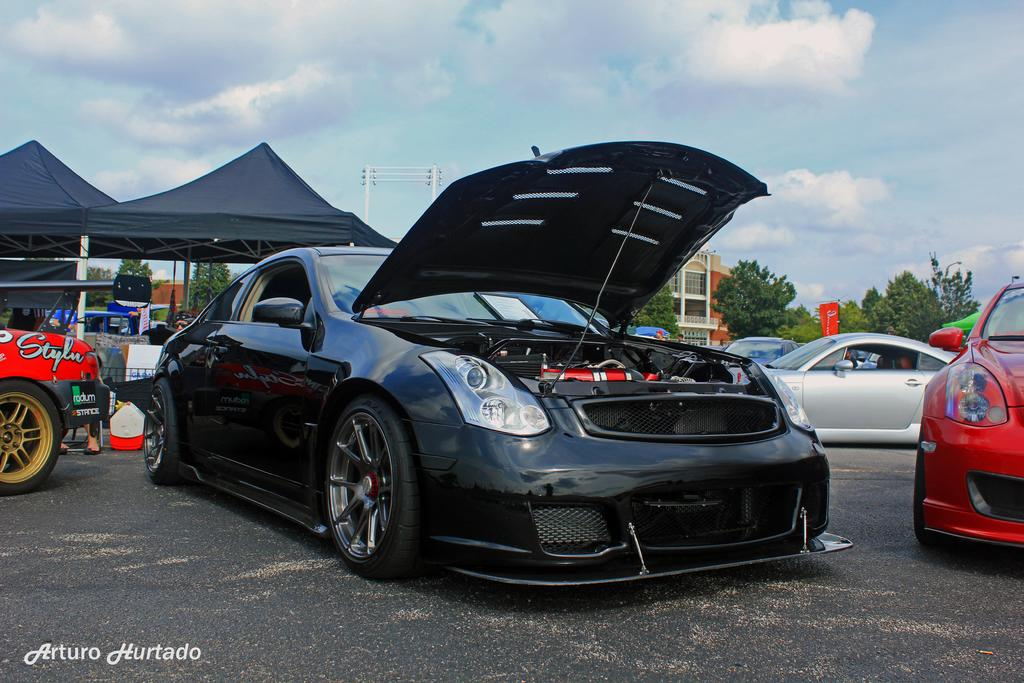What can be seen parked in the image? There are vehicles parked in the image. What structure is present above the parked vehicles? There is a canopy in the image. What type of man-made structures are visible in the image? There are buildings in the image. What type of natural elements are present in the image? There are trees in the image. What tall structures can be seen in the image? There are utility poles in the image. What is visible at the top of the image? The sky is visible in the image. What type of basin is visible in the image? There is no basin present in the image. How does the edge of the canopy affect the taste of the vehicles parked underneath? The edge of the canopy does not affect the taste of the vehicles parked underneath, as it is not related to the taste of the vehicles. 